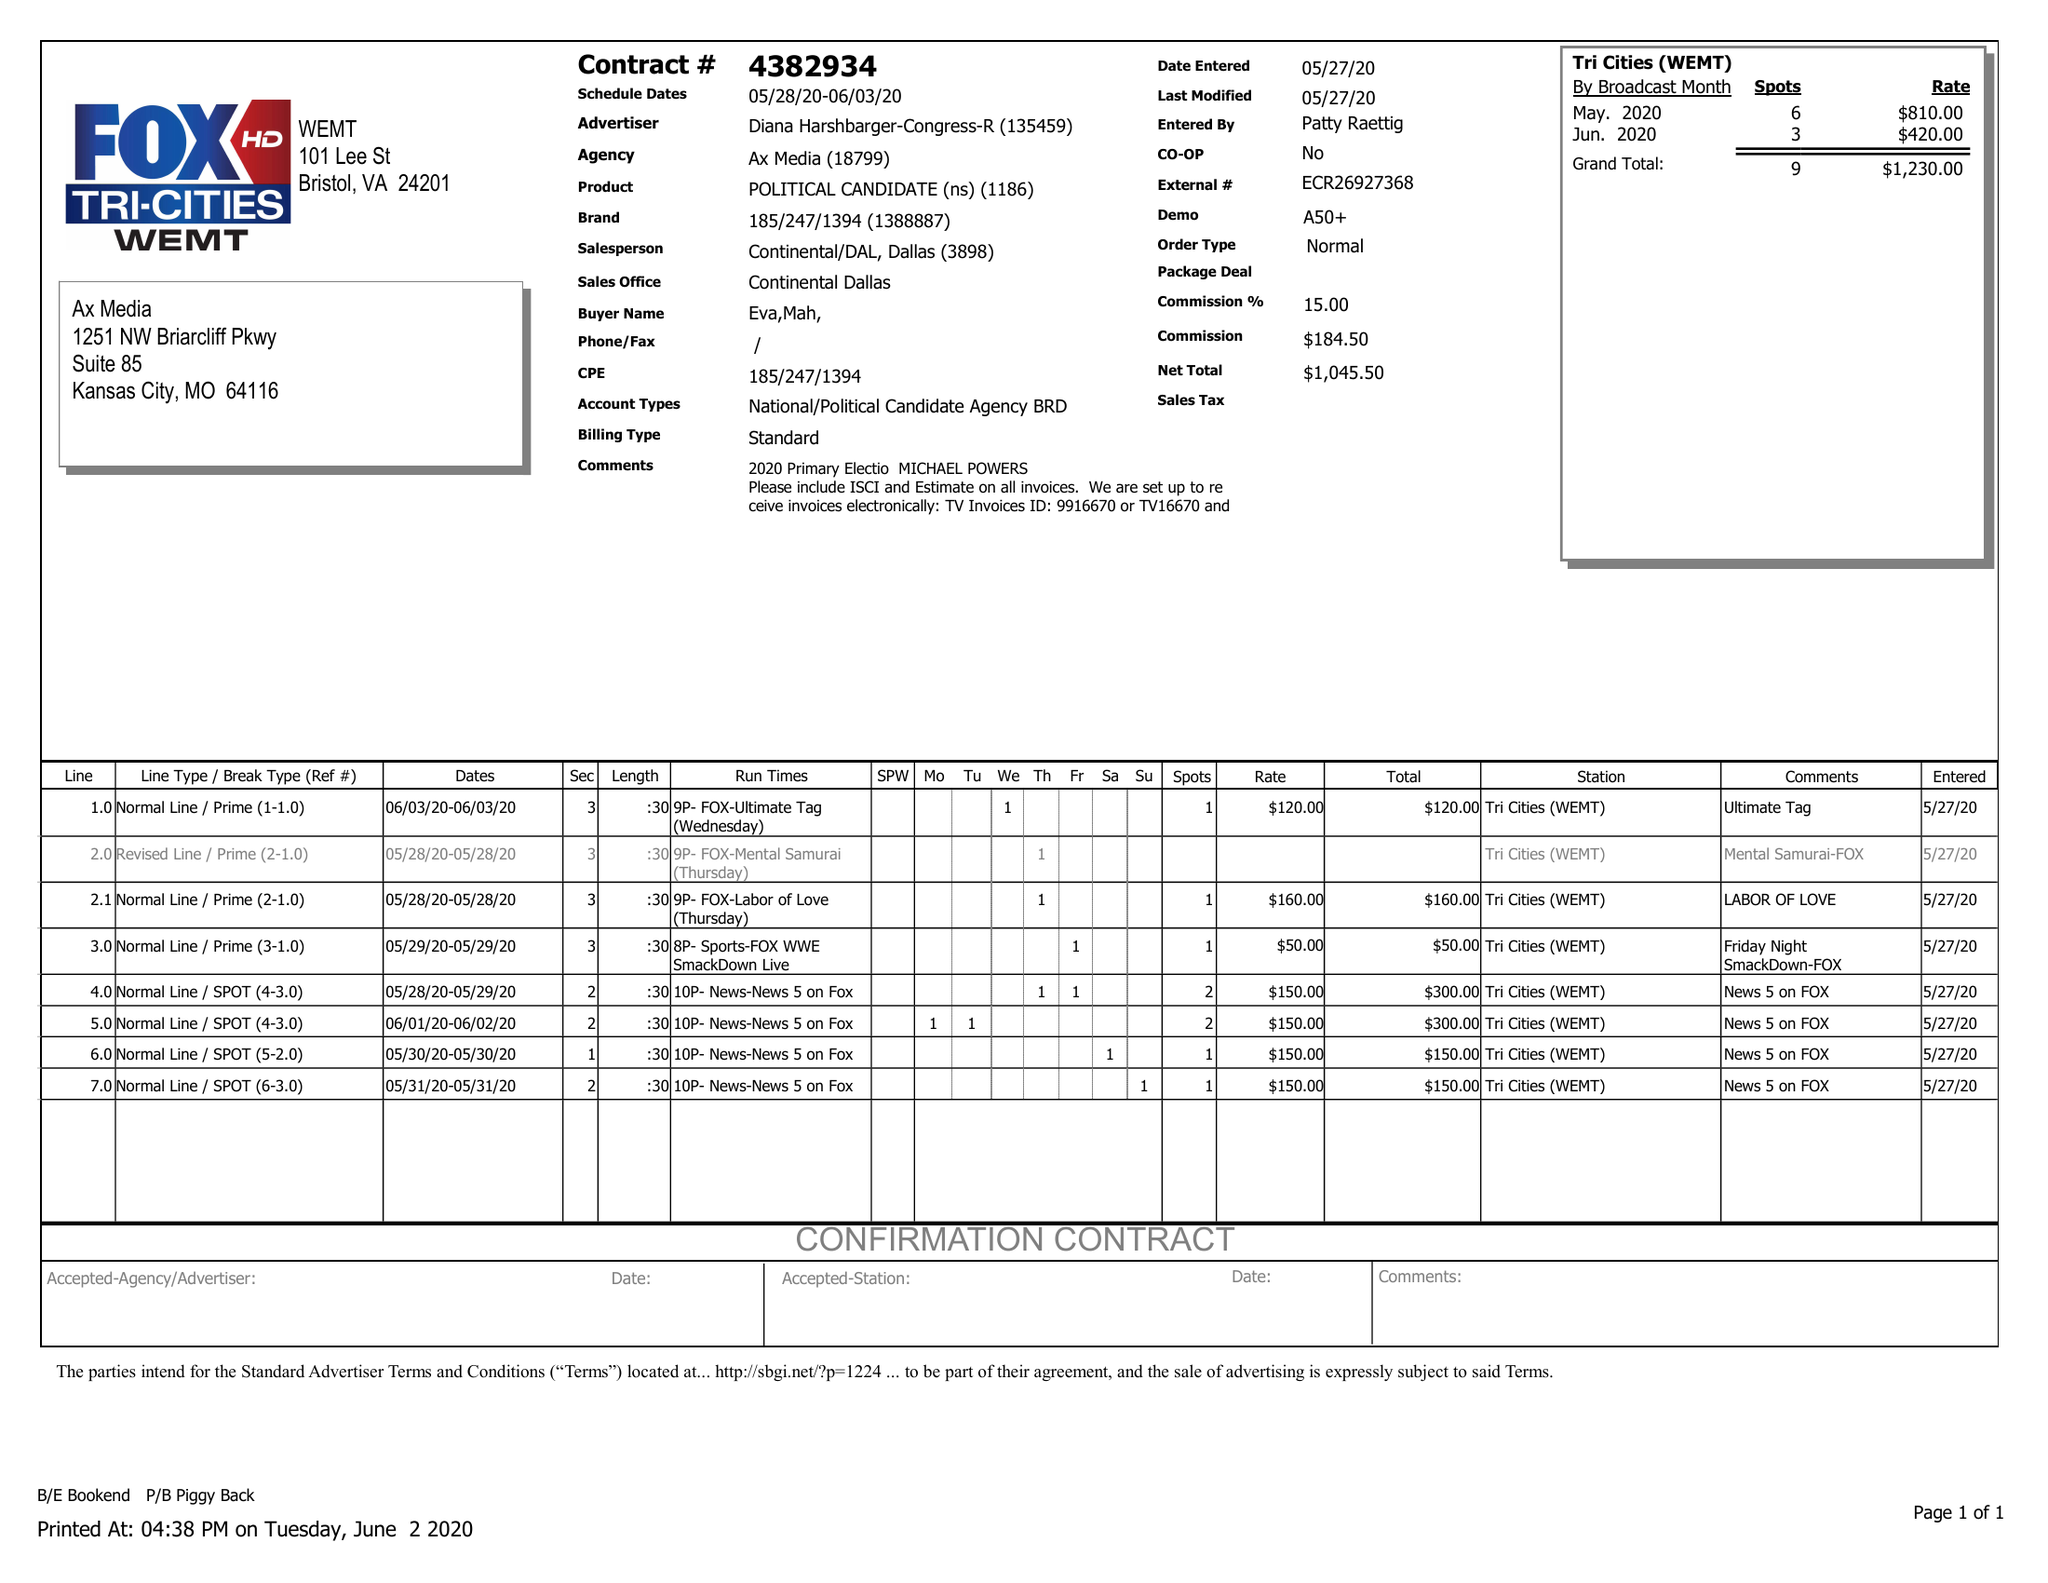What is the value for the advertiser?
Answer the question using a single word or phrase. DIANA HARSHBARGER-CONGRESS-R 